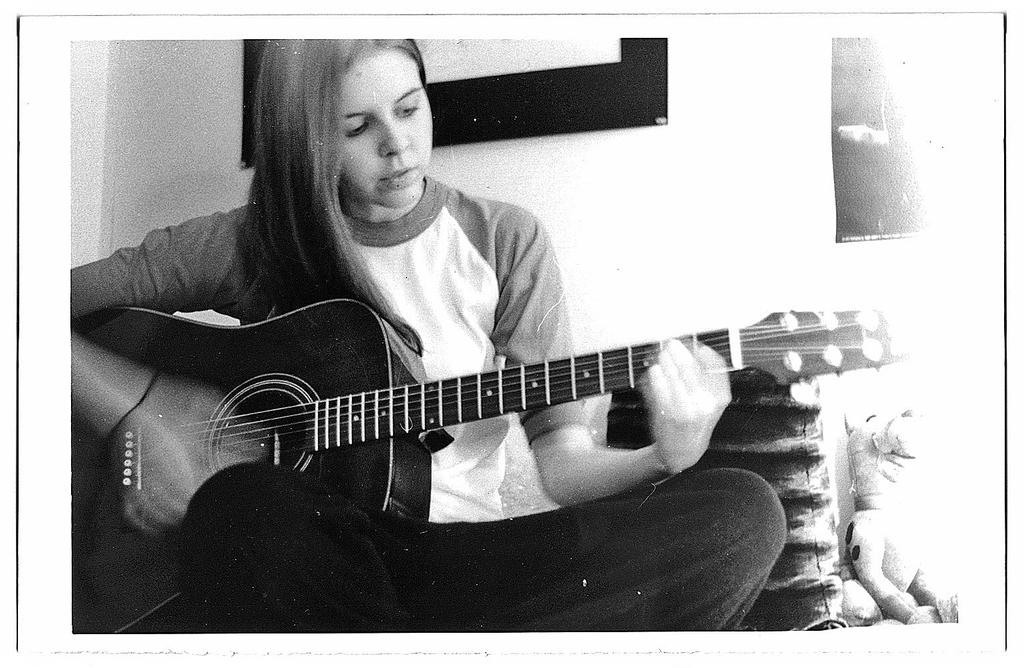Who is the main subject in the image? There is a girl in the image. What type of clothing is the girl wearing? The girl is wearing black pants. What activity is the girl engaged in? The girl is playing a guitar. What other object is present near the girl? There is a toy beside the girl. Do the girl's brothers also play the guitar in the image? There is no mention of the girl having brothers or playing the guitar in the image. What type of rock is visible in the image? There is no rock present in the image. 